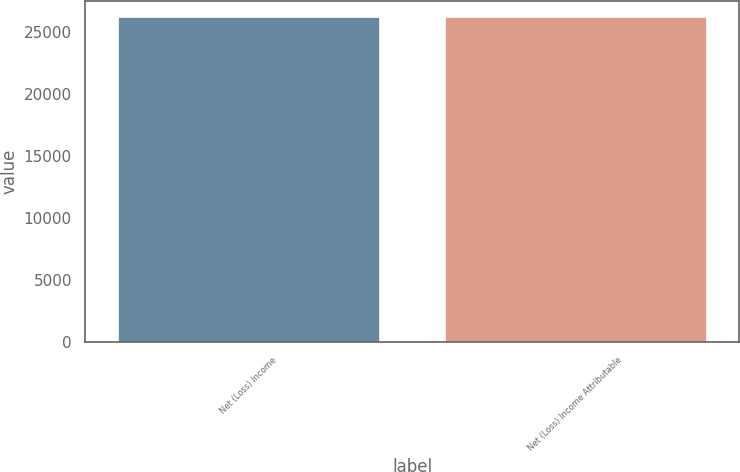Convert chart. <chart><loc_0><loc_0><loc_500><loc_500><bar_chart><fcel>Net (Loss) Income<fcel>Net (Loss) Income Attributable<nl><fcel>26255<fcel>26255.1<nl></chart> 